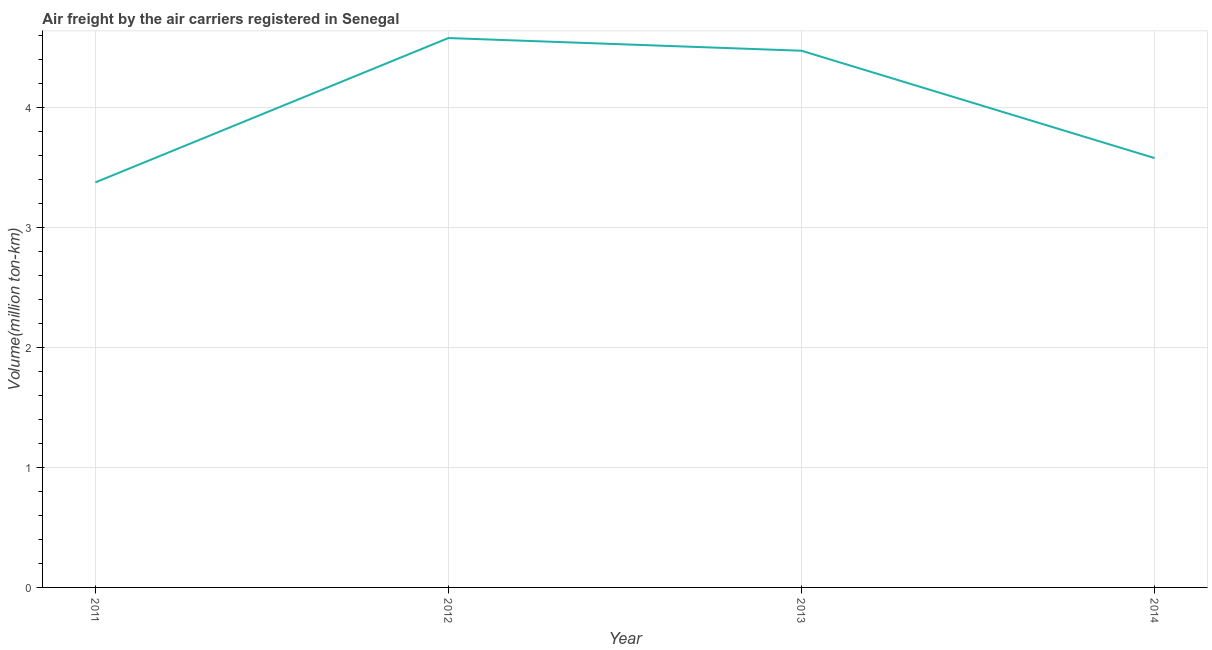What is the air freight in 2011?
Make the answer very short. 3.38. Across all years, what is the maximum air freight?
Give a very brief answer. 4.58. Across all years, what is the minimum air freight?
Provide a succinct answer. 3.38. In which year was the air freight maximum?
Ensure brevity in your answer.  2012. In which year was the air freight minimum?
Provide a succinct answer. 2011. What is the sum of the air freight?
Make the answer very short. 16.01. What is the difference between the air freight in 2011 and 2013?
Offer a very short reply. -1.1. What is the average air freight per year?
Your answer should be very brief. 4. What is the median air freight?
Your answer should be very brief. 4.03. Do a majority of the years between 2011 and 2012 (inclusive) have air freight greater than 4 million ton-km?
Ensure brevity in your answer.  No. What is the ratio of the air freight in 2011 to that in 2012?
Make the answer very short. 0.74. Is the air freight in 2013 less than that in 2014?
Give a very brief answer. No. What is the difference between the highest and the second highest air freight?
Give a very brief answer. 0.11. Is the sum of the air freight in 2012 and 2014 greater than the maximum air freight across all years?
Ensure brevity in your answer.  Yes. What is the difference between the highest and the lowest air freight?
Keep it short and to the point. 1.2. In how many years, is the air freight greater than the average air freight taken over all years?
Keep it short and to the point. 2. Does the air freight monotonically increase over the years?
Make the answer very short. No. Are the values on the major ticks of Y-axis written in scientific E-notation?
Give a very brief answer. No. Does the graph contain any zero values?
Ensure brevity in your answer.  No. Does the graph contain grids?
Keep it short and to the point. Yes. What is the title of the graph?
Your response must be concise. Air freight by the air carriers registered in Senegal. What is the label or title of the X-axis?
Make the answer very short. Year. What is the label or title of the Y-axis?
Your answer should be very brief. Volume(million ton-km). What is the Volume(million ton-km) of 2011?
Your response must be concise. 3.38. What is the Volume(million ton-km) of 2012?
Provide a short and direct response. 4.58. What is the Volume(million ton-km) in 2013?
Give a very brief answer. 4.47. What is the Volume(million ton-km) in 2014?
Give a very brief answer. 3.58. What is the difference between the Volume(million ton-km) in 2011 and 2012?
Your response must be concise. -1.2. What is the difference between the Volume(million ton-km) in 2011 and 2013?
Your response must be concise. -1.1. What is the difference between the Volume(million ton-km) in 2011 and 2014?
Offer a very short reply. -0.2. What is the difference between the Volume(million ton-km) in 2012 and 2013?
Provide a succinct answer. 0.11. What is the difference between the Volume(million ton-km) in 2012 and 2014?
Provide a short and direct response. 1. What is the difference between the Volume(million ton-km) in 2013 and 2014?
Your answer should be compact. 0.89. What is the ratio of the Volume(million ton-km) in 2011 to that in 2012?
Provide a succinct answer. 0.74. What is the ratio of the Volume(million ton-km) in 2011 to that in 2013?
Your response must be concise. 0.76. What is the ratio of the Volume(million ton-km) in 2011 to that in 2014?
Offer a terse response. 0.94. What is the ratio of the Volume(million ton-km) in 2012 to that in 2014?
Keep it short and to the point. 1.28. What is the ratio of the Volume(million ton-km) in 2013 to that in 2014?
Provide a short and direct response. 1.25. 